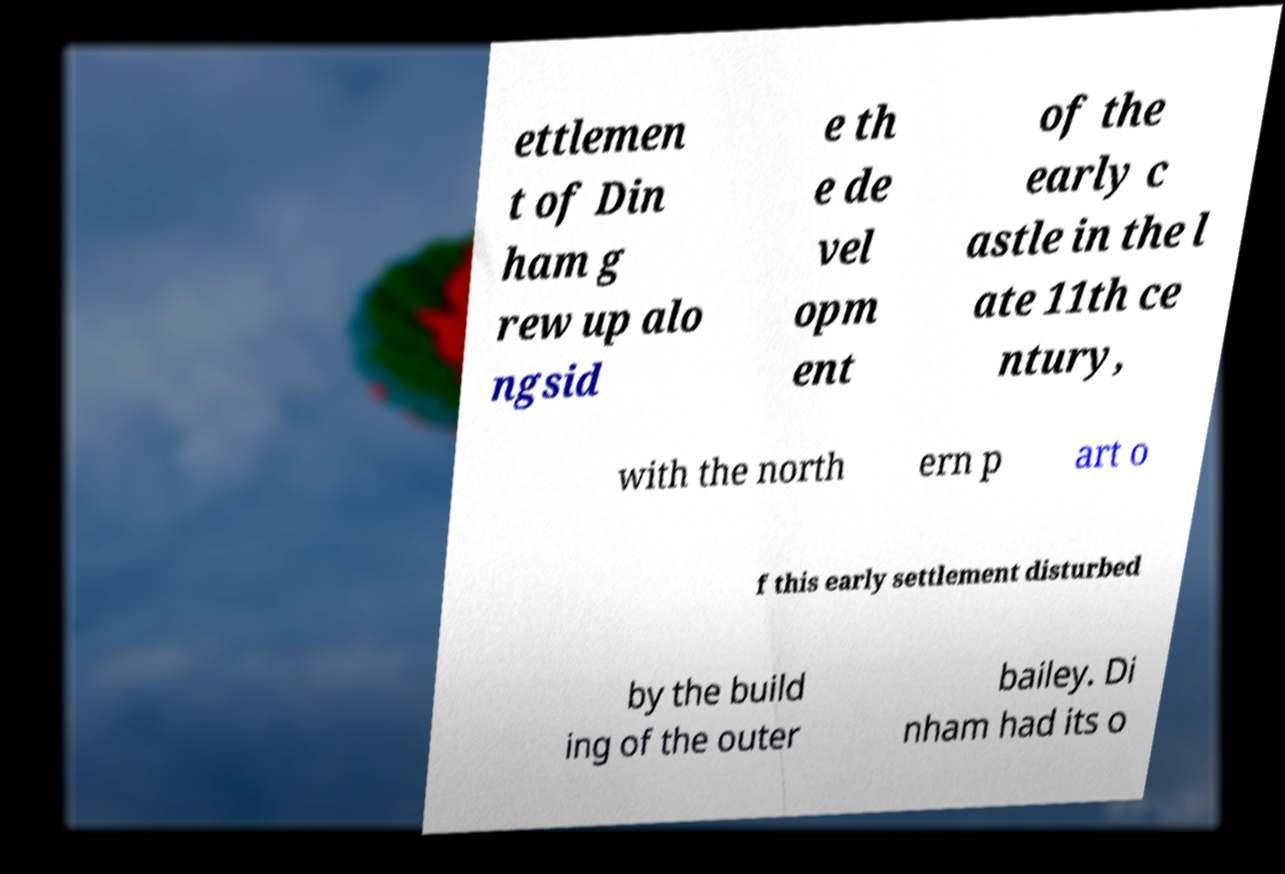Please read and relay the text visible in this image. What does it say? ettlemen t of Din ham g rew up alo ngsid e th e de vel opm ent of the early c astle in the l ate 11th ce ntury, with the north ern p art o f this early settlement disturbed by the build ing of the outer bailey. Di nham had its o 